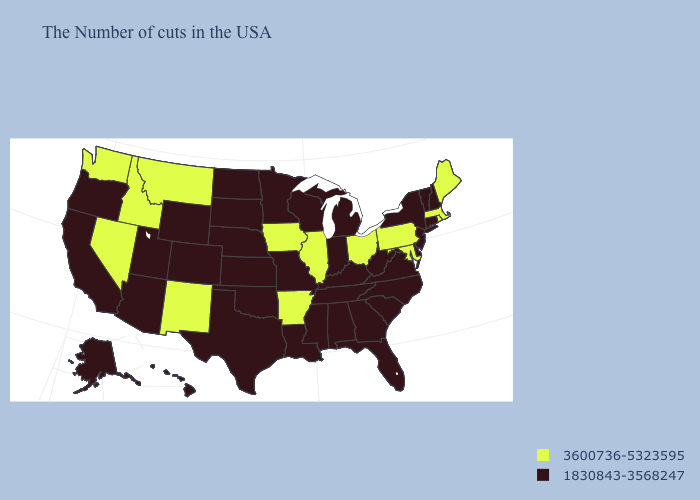Among the states that border Missouri , which have the highest value?
Write a very short answer. Illinois, Arkansas, Iowa. What is the value of West Virginia?
Keep it brief. 1830843-3568247. Does Alaska have a lower value than Colorado?
Answer briefly. No. What is the highest value in the West ?
Quick response, please. 3600736-5323595. What is the value of Alaska?
Short answer required. 1830843-3568247. Which states hav the highest value in the South?
Concise answer only. Maryland, Arkansas. Name the states that have a value in the range 1830843-3568247?
Answer briefly. New Hampshire, Vermont, Connecticut, New York, New Jersey, Delaware, Virginia, North Carolina, South Carolina, West Virginia, Florida, Georgia, Michigan, Kentucky, Indiana, Alabama, Tennessee, Wisconsin, Mississippi, Louisiana, Missouri, Minnesota, Kansas, Nebraska, Oklahoma, Texas, South Dakota, North Dakota, Wyoming, Colorado, Utah, Arizona, California, Oregon, Alaska, Hawaii. What is the value of Hawaii?
Be succinct. 1830843-3568247. Among the states that border California , which have the lowest value?
Be succinct. Arizona, Oregon. Does the first symbol in the legend represent the smallest category?
Quick response, please. No. Which states have the lowest value in the USA?
Write a very short answer. New Hampshire, Vermont, Connecticut, New York, New Jersey, Delaware, Virginia, North Carolina, South Carolina, West Virginia, Florida, Georgia, Michigan, Kentucky, Indiana, Alabama, Tennessee, Wisconsin, Mississippi, Louisiana, Missouri, Minnesota, Kansas, Nebraska, Oklahoma, Texas, South Dakota, North Dakota, Wyoming, Colorado, Utah, Arizona, California, Oregon, Alaska, Hawaii. Does Illinois have the highest value in the USA?
Quick response, please. Yes. What is the highest value in the USA?
Give a very brief answer. 3600736-5323595. What is the value of South Carolina?
Keep it brief. 1830843-3568247. Which states have the lowest value in the USA?
Short answer required. New Hampshire, Vermont, Connecticut, New York, New Jersey, Delaware, Virginia, North Carolina, South Carolina, West Virginia, Florida, Georgia, Michigan, Kentucky, Indiana, Alabama, Tennessee, Wisconsin, Mississippi, Louisiana, Missouri, Minnesota, Kansas, Nebraska, Oklahoma, Texas, South Dakota, North Dakota, Wyoming, Colorado, Utah, Arizona, California, Oregon, Alaska, Hawaii. 